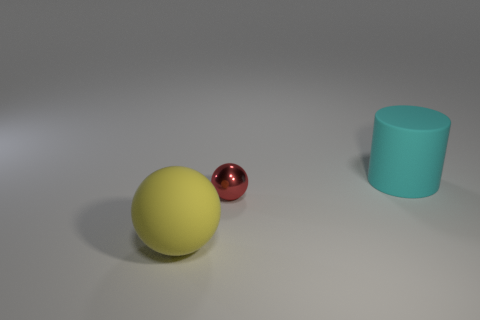There is a large cylinder that is behind the yellow ball; how many small metal things are left of it?
Your answer should be compact. 1. Are there any blue matte things of the same shape as the large yellow object?
Offer a terse response. No. Is the size of the rubber thing that is to the left of the big cyan thing the same as the rubber thing that is behind the large sphere?
Ensure brevity in your answer.  Yes. There is a rubber thing in front of the large rubber thing right of the large yellow ball; what is its shape?
Provide a succinct answer. Sphere. How many shiny objects are the same size as the yellow ball?
Your response must be concise. 0. Is there a gray rubber sphere?
Provide a succinct answer. No. What is the shape of the cyan object that is the same material as the large ball?
Offer a very short reply. Cylinder. What color is the large thing on the right side of the big rubber thing to the left of the large thing that is behind the shiny thing?
Offer a terse response. Cyan. Are there an equal number of large matte spheres to the right of the cyan thing and cyan rubber things?
Give a very brief answer. No. Is there any other thing that has the same material as the tiny red object?
Your answer should be compact. No. 